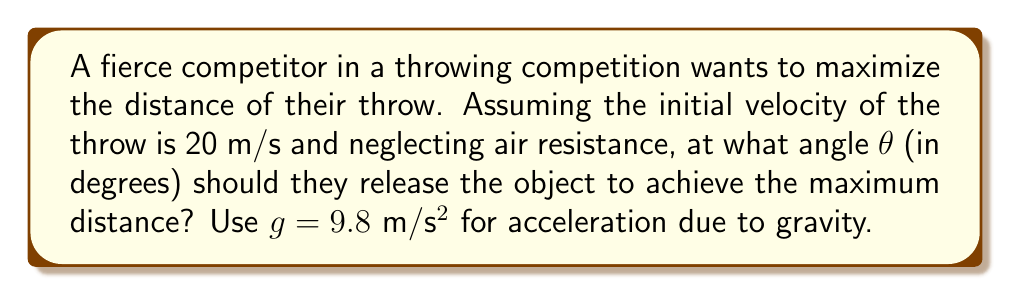What is the answer to this math problem? To solve this problem, we need to use the equations of projectile motion and optimize for maximum range.

1) The range (R) of a projectile launched at an angle θ with initial velocity v₀ is given by:

   $$ R = \frac{v_0^2 \sin(2\theta)}{g} $$

2) To find the maximum range, we need to maximize sin(2θ). The maximum value of sine is 1, which occurs when its argument is 90°.

3) Therefore, for maximum range:

   $$ 2\theta = 90° $$
   $$ \theta = 45° $$

4) We can verify this mathematically by taking the derivative of R with respect to θ and setting it to zero:

   $$ \frac{dR}{d\theta} = \frac{2v_0^2 \cos(2\theta)}{g} = 0 $$

   This is true when cos(2θ) = 0, which occurs when 2θ = 90°, confirming our result.

5) For a fierce competitor with exceptional mechanical skill, this 45° angle provides the optimal balance between vertical and horizontal components of velocity, maximizing the throw distance.

Note: In real-world scenarios, factors like air resistance and the height of release might slightly alter this optimal angle, but 45° remains a good approximation for most throwing competitions.
Answer: The optimal angle for maximum distance in the throwing competition is 45°. 